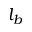<formula> <loc_0><loc_0><loc_500><loc_500>l _ { b }</formula> 